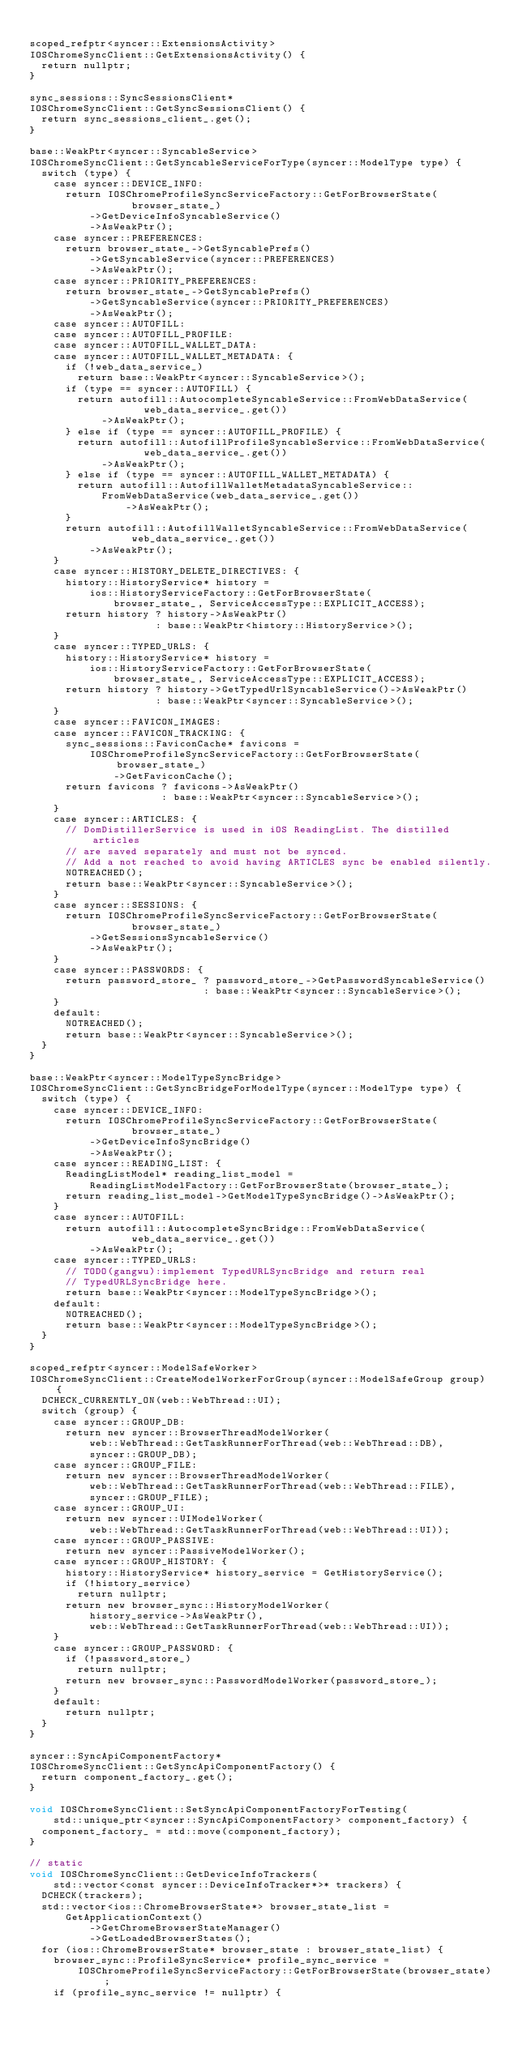Convert code to text. <code><loc_0><loc_0><loc_500><loc_500><_ObjectiveC_>
scoped_refptr<syncer::ExtensionsActivity>
IOSChromeSyncClient::GetExtensionsActivity() {
  return nullptr;
}

sync_sessions::SyncSessionsClient*
IOSChromeSyncClient::GetSyncSessionsClient() {
  return sync_sessions_client_.get();
}

base::WeakPtr<syncer::SyncableService>
IOSChromeSyncClient::GetSyncableServiceForType(syncer::ModelType type) {
  switch (type) {
    case syncer::DEVICE_INFO:
      return IOSChromeProfileSyncServiceFactory::GetForBrowserState(
                 browser_state_)
          ->GetDeviceInfoSyncableService()
          ->AsWeakPtr();
    case syncer::PREFERENCES:
      return browser_state_->GetSyncablePrefs()
          ->GetSyncableService(syncer::PREFERENCES)
          ->AsWeakPtr();
    case syncer::PRIORITY_PREFERENCES:
      return browser_state_->GetSyncablePrefs()
          ->GetSyncableService(syncer::PRIORITY_PREFERENCES)
          ->AsWeakPtr();
    case syncer::AUTOFILL:
    case syncer::AUTOFILL_PROFILE:
    case syncer::AUTOFILL_WALLET_DATA:
    case syncer::AUTOFILL_WALLET_METADATA: {
      if (!web_data_service_)
        return base::WeakPtr<syncer::SyncableService>();
      if (type == syncer::AUTOFILL) {
        return autofill::AutocompleteSyncableService::FromWebDataService(
                   web_data_service_.get())
            ->AsWeakPtr();
      } else if (type == syncer::AUTOFILL_PROFILE) {
        return autofill::AutofillProfileSyncableService::FromWebDataService(
                   web_data_service_.get())
            ->AsWeakPtr();
      } else if (type == syncer::AUTOFILL_WALLET_METADATA) {
        return autofill::AutofillWalletMetadataSyncableService::
            FromWebDataService(web_data_service_.get())
                ->AsWeakPtr();
      }
      return autofill::AutofillWalletSyncableService::FromWebDataService(
                 web_data_service_.get())
          ->AsWeakPtr();
    }
    case syncer::HISTORY_DELETE_DIRECTIVES: {
      history::HistoryService* history =
          ios::HistoryServiceFactory::GetForBrowserState(
              browser_state_, ServiceAccessType::EXPLICIT_ACCESS);
      return history ? history->AsWeakPtr()
                     : base::WeakPtr<history::HistoryService>();
    }
    case syncer::TYPED_URLS: {
      history::HistoryService* history =
          ios::HistoryServiceFactory::GetForBrowserState(
              browser_state_, ServiceAccessType::EXPLICIT_ACCESS);
      return history ? history->GetTypedUrlSyncableService()->AsWeakPtr()
                     : base::WeakPtr<syncer::SyncableService>();
    }
    case syncer::FAVICON_IMAGES:
    case syncer::FAVICON_TRACKING: {
      sync_sessions::FaviconCache* favicons =
          IOSChromeProfileSyncServiceFactory::GetForBrowserState(browser_state_)
              ->GetFaviconCache();
      return favicons ? favicons->AsWeakPtr()
                      : base::WeakPtr<syncer::SyncableService>();
    }
    case syncer::ARTICLES: {
      // DomDistillerService is used in iOS ReadingList. The distilled articles
      // are saved separately and must not be synced.
      // Add a not reached to avoid having ARTICLES sync be enabled silently.
      NOTREACHED();
      return base::WeakPtr<syncer::SyncableService>();
    }
    case syncer::SESSIONS: {
      return IOSChromeProfileSyncServiceFactory::GetForBrowserState(
                 browser_state_)
          ->GetSessionsSyncableService()
          ->AsWeakPtr();
    }
    case syncer::PASSWORDS: {
      return password_store_ ? password_store_->GetPasswordSyncableService()
                             : base::WeakPtr<syncer::SyncableService>();
    }
    default:
      NOTREACHED();
      return base::WeakPtr<syncer::SyncableService>();
  }
}

base::WeakPtr<syncer::ModelTypeSyncBridge>
IOSChromeSyncClient::GetSyncBridgeForModelType(syncer::ModelType type) {
  switch (type) {
    case syncer::DEVICE_INFO:
      return IOSChromeProfileSyncServiceFactory::GetForBrowserState(
                 browser_state_)
          ->GetDeviceInfoSyncBridge()
          ->AsWeakPtr();
    case syncer::READING_LIST: {
      ReadingListModel* reading_list_model =
          ReadingListModelFactory::GetForBrowserState(browser_state_);
      return reading_list_model->GetModelTypeSyncBridge()->AsWeakPtr();
    }
    case syncer::AUTOFILL:
      return autofill::AutocompleteSyncBridge::FromWebDataService(
                 web_data_service_.get())
          ->AsWeakPtr();
    case syncer::TYPED_URLS:
      // TODO(gangwu):implement TypedURLSyncBridge and return real
      // TypedURLSyncBridge here.
      return base::WeakPtr<syncer::ModelTypeSyncBridge>();
    default:
      NOTREACHED();
      return base::WeakPtr<syncer::ModelTypeSyncBridge>();
  }
}

scoped_refptr<syncer::ModelSafeWorker>
IOSChromeSyncClient::CreateModelWorkerForGroup(syncer::ModelSafeGroup group) {
  DCHECK_CURRENTLY_ON(web::WebThread::UI);
  switch (group) {
    case syncer::GROUP_DB:
      return new syncer::BrowserThreadModelWorker(
          web::WebThread::GetTaskRunnerForThread(web::WebThread::DB),
          syncer::GROUP_DB);
    case syncer::GROUP_FILE:
      return new syncer::BrowserThreadModelWorker(
          web::WebThread::GetTaskRunnerForThread(web::WebThread::FILE),
          syncer::GROUP_FILE);
    case syncer::GROUP_UI:
      return new syncer::UIModelWorker(
          web::WebThread::GetTaskRunnerForThread(web::WebThread::UI));
    case syncer::GROUP_PASSIVE:
      return new syncer::PassiveModelWorker();
    case syncer::GROUP_HISTORY: {
      history::HistoryService* history_service = GetHistoryService();
      if (!history_service)
        return nullptr;
      return new browser_sync::HistoryModelWorker(
          history_service->AsWeakPtr(),
          web::WebThread::GetTaskRunnerForThread(web::WebThread::UI));
    }
    case syncer::GROUP_PASSWORD: {
      if (!password_store_)
        return nullptr;
      return new browser_sync::PasswordModelWorker(password_store_);
    }
    default:
      return nullptr;
  }
}

syncer::SyncApiComponentFactory*
IOSChromeSyncClient::GetSyncApiComponentFactory() {
  return component_factory_.get();
}

void IOSChromeSyncClient::SetSyncApiComponentFactoryForTesting(
    std::unique_ptr<syncer::SyncApiComponentFactory> component_factory) {
  component_factory_ = std::move(component_factory);
}

// static
void IOSChromeSyncClient::GetDeviceInfoTrackers(
    std::vector<const syncer::DeviceInfoTracker*>* trackers) {
  DCHECK(trackers);
  std::vector<ios::ChromeBrowserState*> browser_state_list =
      GetApplicationContext()
          ->GetChromeBrowserStateManager()
          ->GetLoadedBrowserStates();
  for (ios::ChromeBrowserState* browser_state : browser_state_list) {
    browser_sync::ProfileSyncService* profile_sync_service =
        IOSChromeProfileSyncServiceFactory::GetForBrowserState(browser_state);
    if (profile_sync_service != nullptr) {</code> 